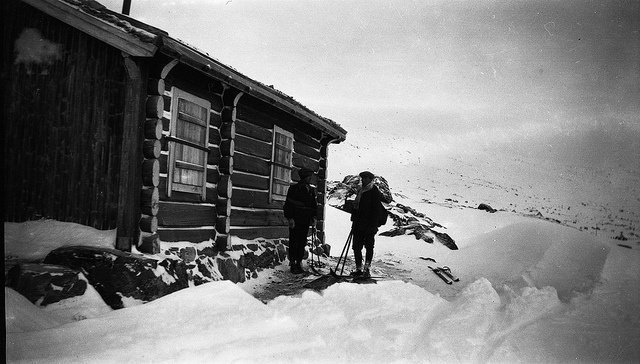Describe the objects in this image and their specific colors. I can see people in black, gray, darkgray, and lightgray tones, people in black, gray, darkgray, and lightgray tones, skis in black, darkgray, gray, and lightgray tones, and skis in black and gray tones in this image. 